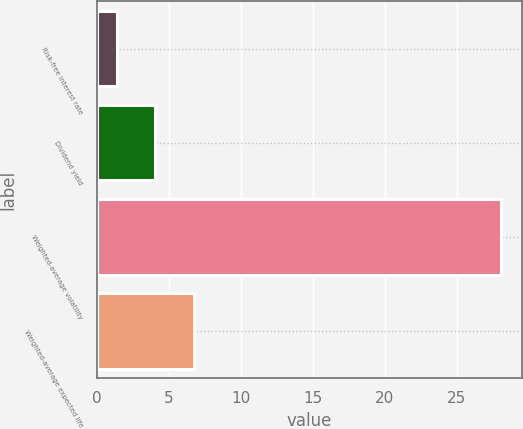Convert chart. <chart><loc_0><loc_0><loc_500><loc_500><bar_chart><fcel>Risk-free interest rate<fcel>Dividend yield<fcel>Weighted-average volatility<fcel>Weighted-average expected life<nl><fcel>1.4<fcel>4.07<fcel>28.1<fcel>6.74<nl></chart> 